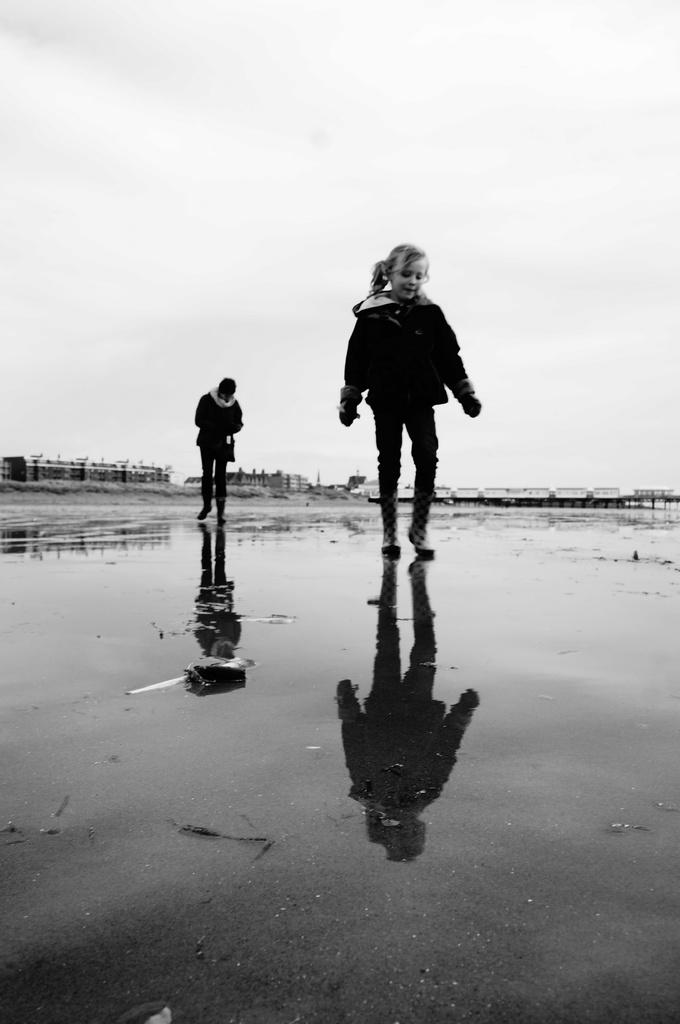What are the two persons in the image doing? The two persons are walking on the water. What can be seen in the background of the image? There are buildings visible in the image. What is the condition of the sky in the image? The sky is clear in the image. Reasoning: Let' Let's think step by step in order to produce the conversation. We start by identifying the main action of the two persons in the image, which is walking on the water. Then, we describe the background of the image, which includes buildings. Finally, we mention the condition of the sky, which is clear. Absurd Question/Answer: Can you see a girl walking on the water in the image? There is no girl present in the image; it features two persons walking on the water. What type of vessel is floating on the water in the image? There is no vessel present in the image; the two persons are walking on the water without any visible means of support. Can you see a girl walking on the water in the image? There is no girl present in the image; it features two persons walking on the water. What type of vessel is floating on the water in the image? There is no vessel present in the image; the two persons are walking on the water without any visible means of support. 